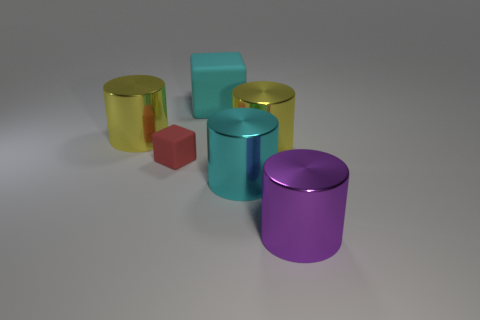Can you describe the colors and shapes of the objects in the image? Certainly! There are five cylinders and one cube in the image. From left to right: a yellow cylinder, a gold cylinder, a cyan cube, a teal cylinder, and a purple cylinder. The cube has a matte finish, while the cylinders appear to have a reflective surface. 